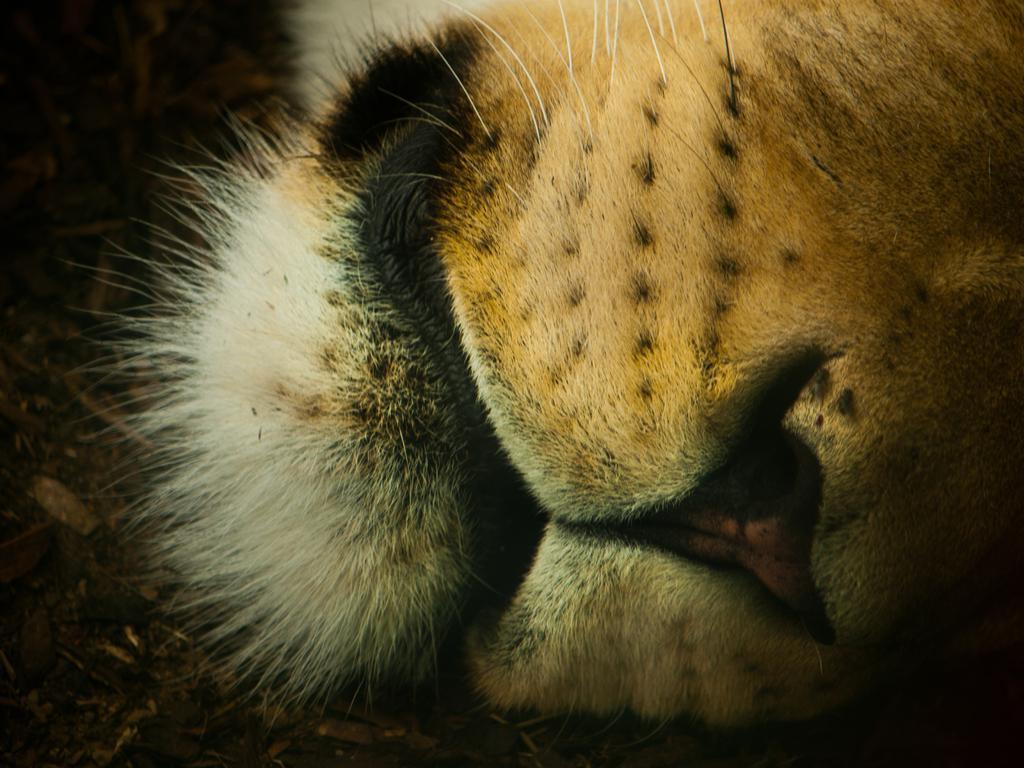How would you summarize this image in a sentence or two? In this picture we can see an animal's mouth here. 